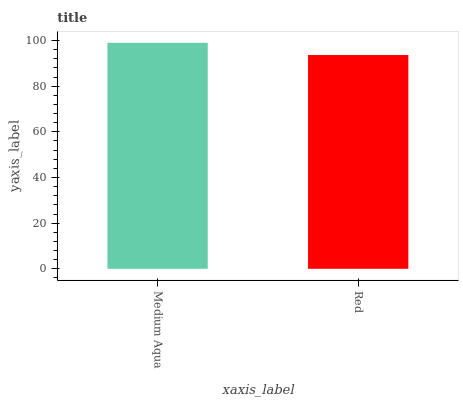Is Red the maximum?
Answer yes or no. No. Is Medium Aqua greater than Red?
Answer yes or no. Yes. Is Red less than Medium Aqua?
Answer yes or no. Yes. Is Red greater than Medium Aqua?
Answer yes or no. No. Is Medium Aqua less than Red?
Answer yes or no. No. Is Medium Aqua the high median?
Answer yes or no. Yes. Is Red the low median?
Answer yes or no. Yes. Is Red the high median?
Answer yes or no. No. Is Medium Aqua the low median?
Answer yes or no. No. 